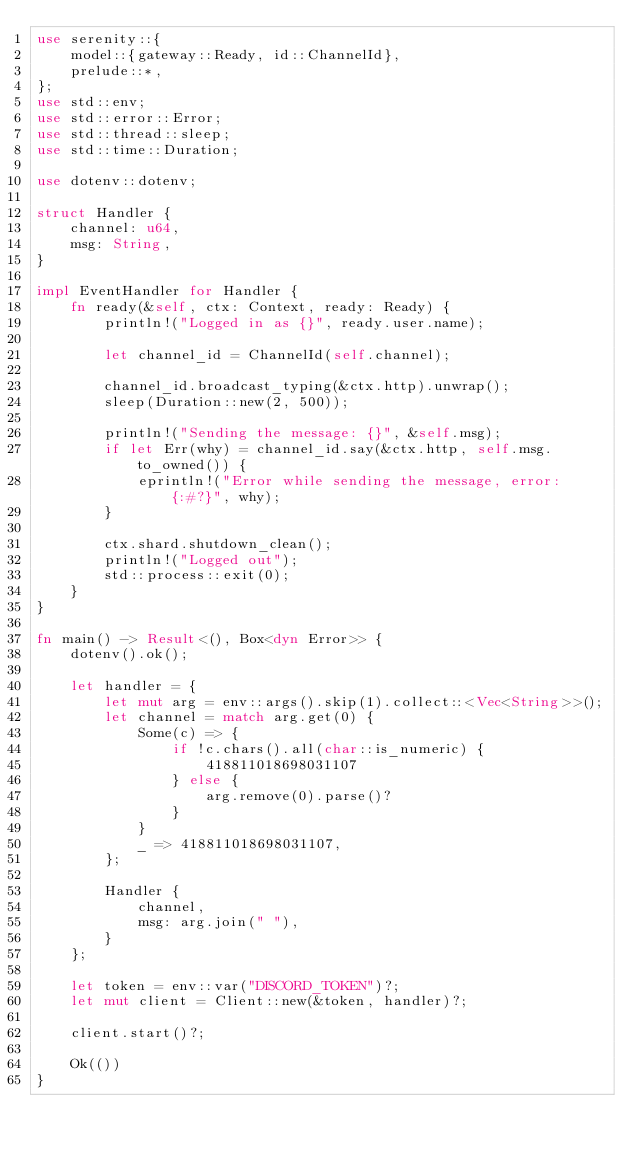Convert code to text. <code><loc_0><loc_0><loc_500><loc_500><_Rust_>use serenity::{
    model::{gateway::Ready, id::ChannelId},
    prelude::*,
};
use std::env;
use std::error::Error;
use std::thread::sleep;
use std::time::Duration;

use dotenv::dotenv;

struct Handler {
    channel: u64,
    msg: String,
}

impl EventHandler for Handler {
    fn ready(&self, ctx: Context, ready: Ready) {
        println!("Logged in as {}", ready.user.name);

        let channel_id = ChannelId(self.channel);

        channel_id.broadcast_typing(&ctx.http).unwrap();
        sleep(Duration::new(2, 500));

        println!("Sending the message: {}", &self.msg);
        if let Err(why) = channel_id.say(&ctx.http, self.msg.to_owned()) {
            eprintln!("Error while sending the message, error: {:#?}", why);
        }

        ctx.shard.shutdown_clean();
        println!("Logged out");
        std::process::exit(0);
    }
}

fn main() -> Result<(), Box<dyn Error>> {
    dotenv().ok();

    let handler = {
        let mut arg = env::args().skip(1).collect::<Vec<String>>();
        let channel = match arg.get(0) {
            Some(c) => {
                if !c.chars().all(char::is_numeric) {
                    418811018698031107
                } else {
                    arg.remove(0).parse()?
                }
            }
            _ => 418811018698031107,
        };

        Handler {
            channel,
            msg: arg.join(" "),
        }
    };

    let token = env::var("DISCORD_TOKEN")?;
    let mut client = Client::new(&token, handler)?;

    client.start()?;

    Ok(())
}
</code> 